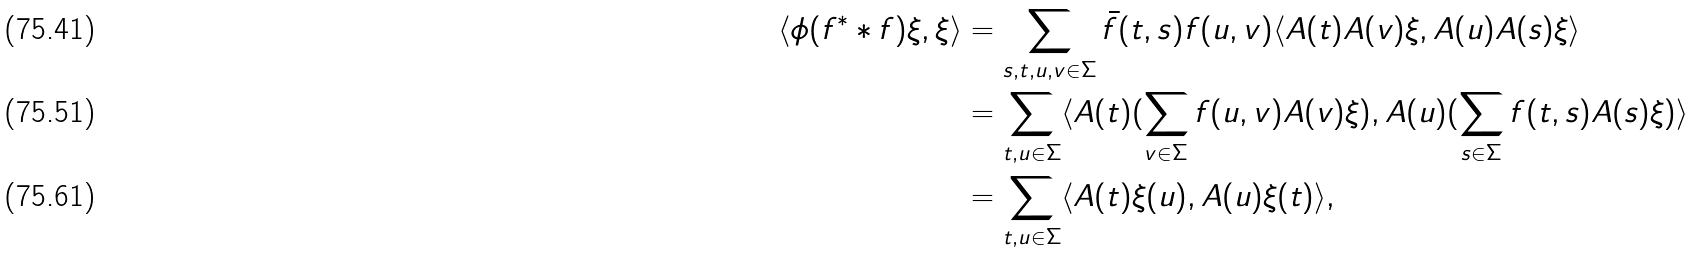Convert formula to latex. <formula><loc_0><loc_0><loc_500><loc_500>\langle \phi ( f ^ { * } * f ) \xi , \xi \rangle & = \sum _ { s , t , u , v \in \Sigma } \bar { f } ( t , s ) f ( u , v ) \langle A ( t ) A ( v ) \xi , A ( u ) A ( s ) \xi \rangle \\ & = \sum _ { t , u \in \Sigma } \langle A ( t ) ( \sum _ { v \in \Sigma } f ( u , v ) A ( v ) \xi ) , A ( u ) ( \sum _ { s \in \Sigma } f ( t , s ) A ( s ) \xi ) \rangle \\ & = \sum _ { t , u \in \Sigma } \langle A ( t ) \xi ( u ) , A ( u ) \xi ( t ) \rangle ,</formula> 